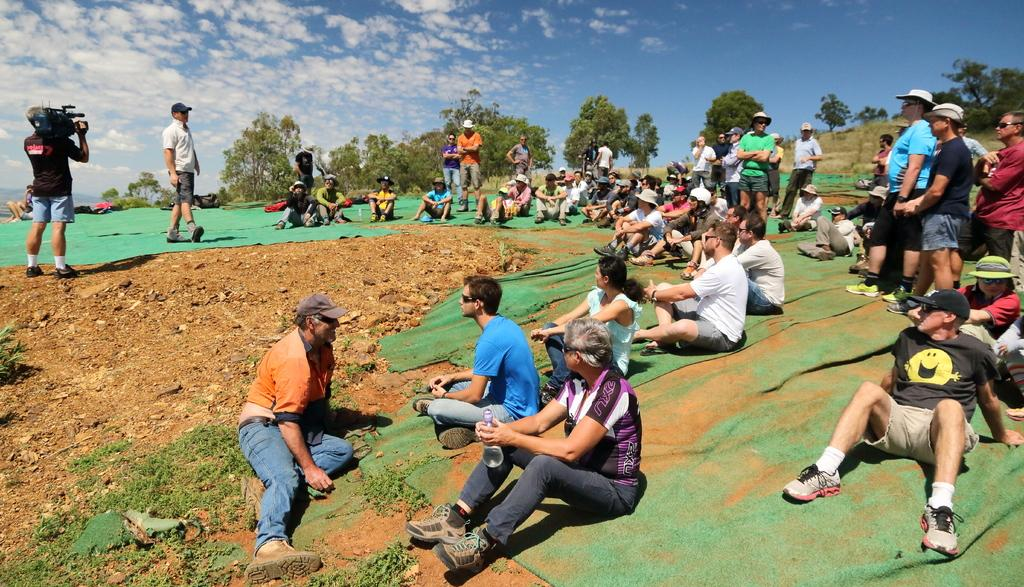What are the people in the image doing? There are people sitting and standing in the image. What can be seen in the background of the image? There are trees visible in the background of the image. How long does it take for the people to drop their hats in the image? There is no mention of hats or dropping them in the image, so it's not possible to answer that question. 